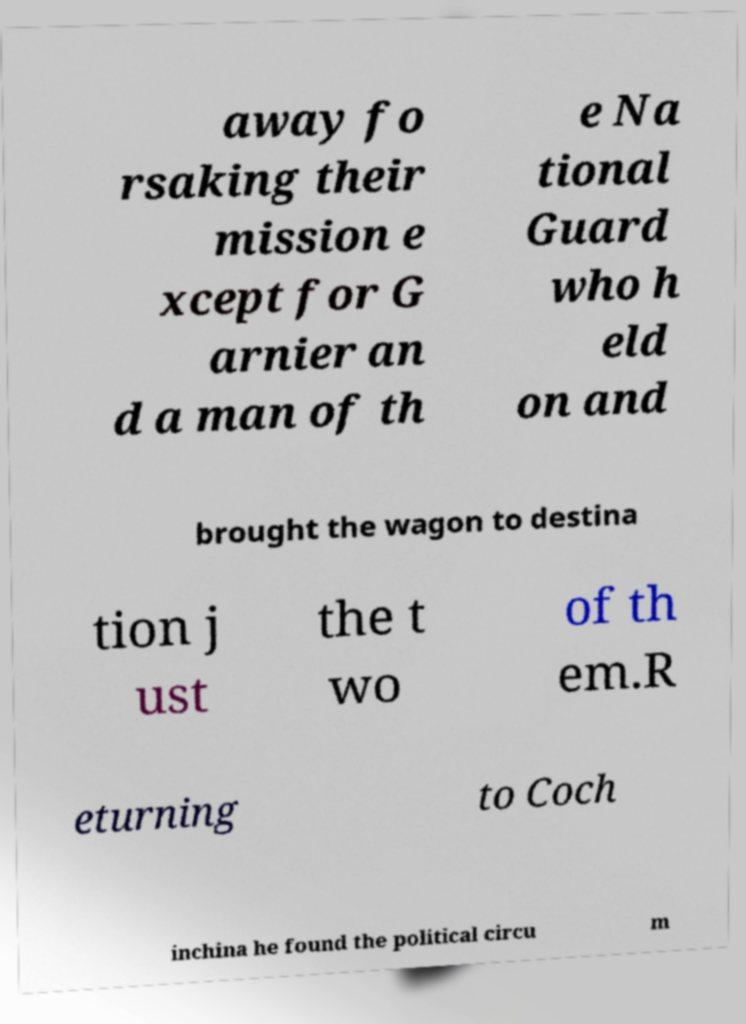I need the written content from this picture converted into text. Can you do that? away fo rsaking their mission e xcept for G arnier an d a man of th e Na tional Guard who h eld on and brought the wagon to destina tion j ust the t wo of th em.R eturning to Coch inchina he found the political circu m 